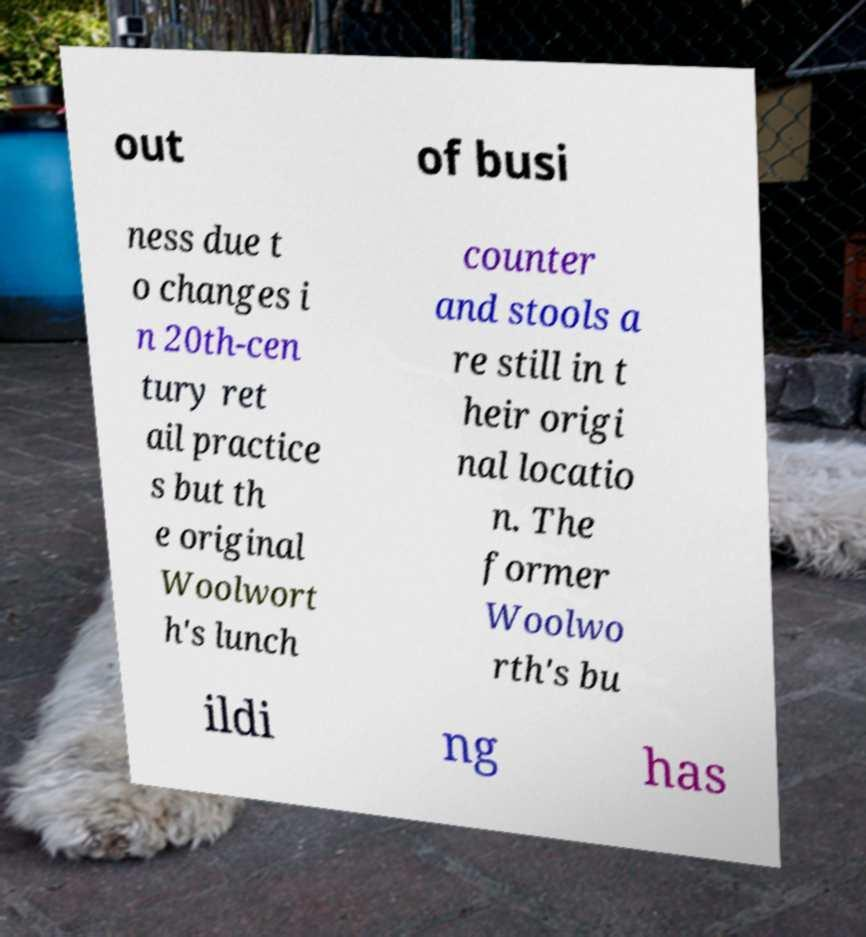Can you accurately transcribe the text from the provided image for me? out of busi ness due t o changes i n 20th-cen tury ret ail practice s but th e original Woolwort h's lunch counter and stools a re still in t heir origi nal locatio n. The former Woolwo rth's bu ildi ng has 